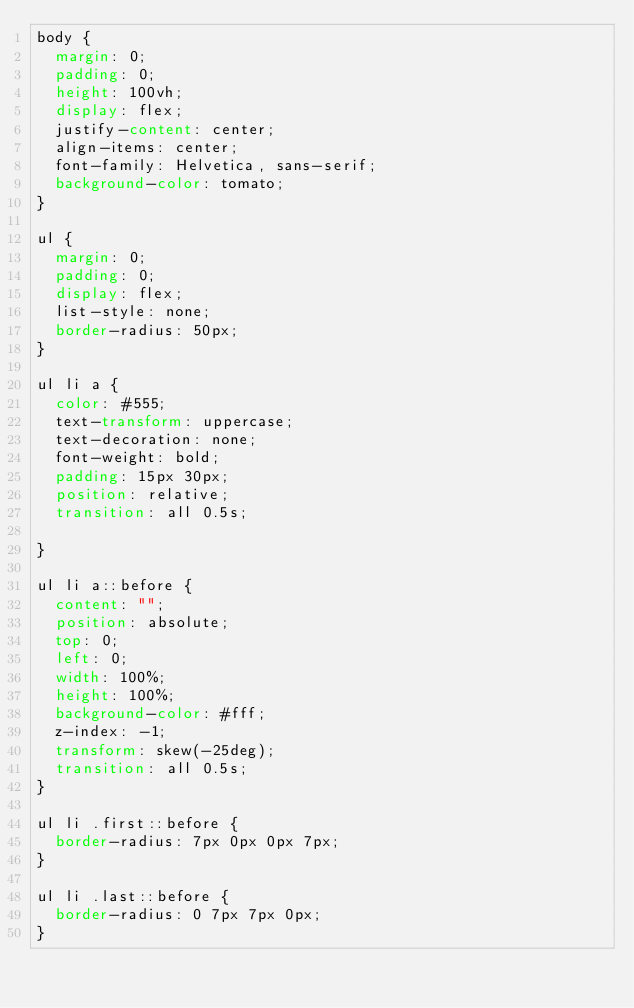<code> <loc_0><loc_0><loc_500><loc_500><_CSS_>body {
  margin: 0;
  padding: 0;
  height: 100vh;
  display: flex;
  justify-content: center;
  align-items: center;
  font-family: Helvetica, sans-serif;
  background-color: tomato;
}

ul {
  margin: 0;
  padding: 0;
  display: flex;
  list-style: none;
  border-radius: 50px;
}

ul li a {
  color: #555;
  text-transform: uppercase;
  text-decoration: none;
  font-weight: bold;
  padding: 15px 30px;
  position: relative;
  transition: all 0.5s;

}

ul li a::before {
  content: "";
  position: absolute;
  top: 0;
  left: 0;
  width: 100%;
  height: 100%;
  background-color: #fff;
  z-index: -1;
  transform: skew(-25deg);
  transition: all 0.5s;
}

ul li .first::before {
  border-radius: 7px 0px 0px 7px;
}

ul li .last::before {
  border-radius: 0 7px 7px 0px;
}
</code> 